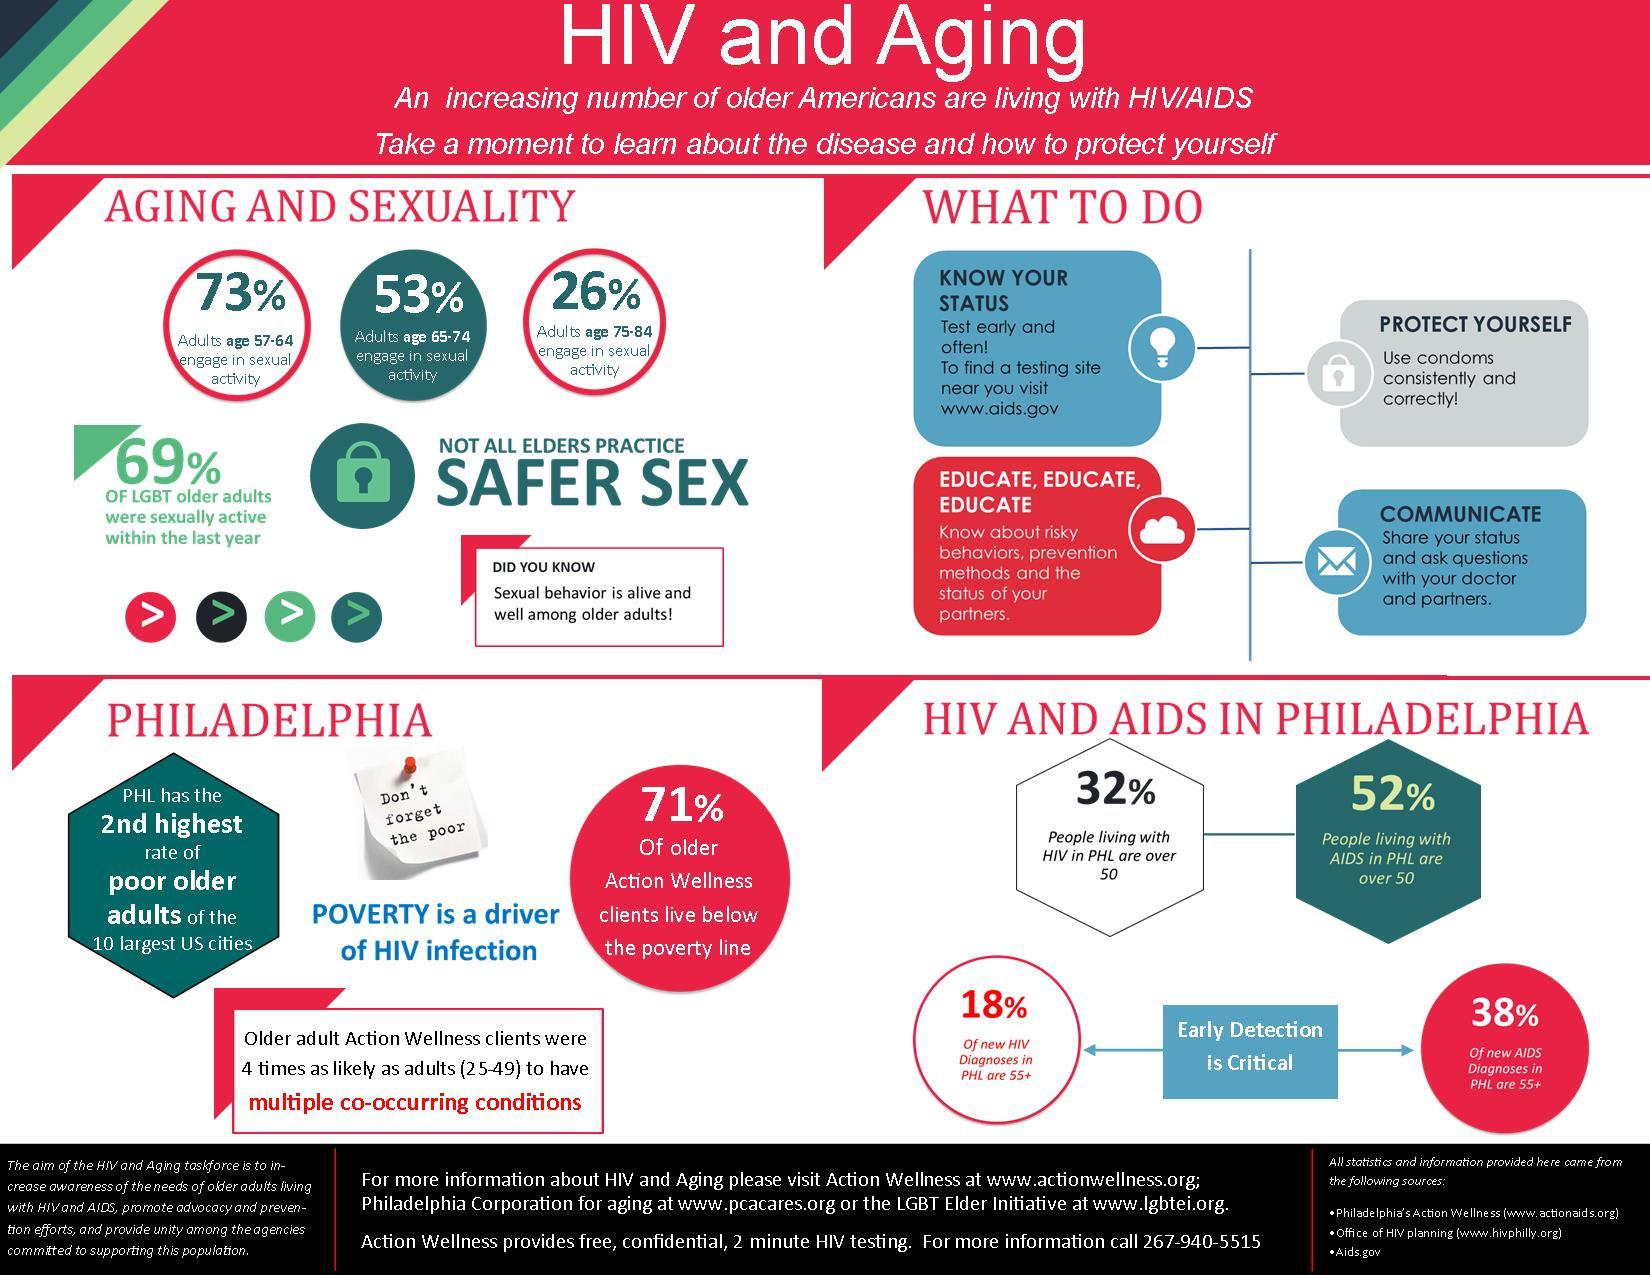Indicate a few pertinent items in this graphic. In Philadelphia, 38% of new AIDS cases were diagnosed in individuals aged 55 and older. In America, 53% of adults in the age group of 65-74 are engaged in sexual activity. According to a recent survey, 27% of adults in the age group of 57-64 in America do not engage in sexual activity. In Philadelphia, 18% of new HIV cases were diagnosed in individuals aged 55 and above. A recent study found that 31% of LGBT older adults in America were not sexually active within the last year. 